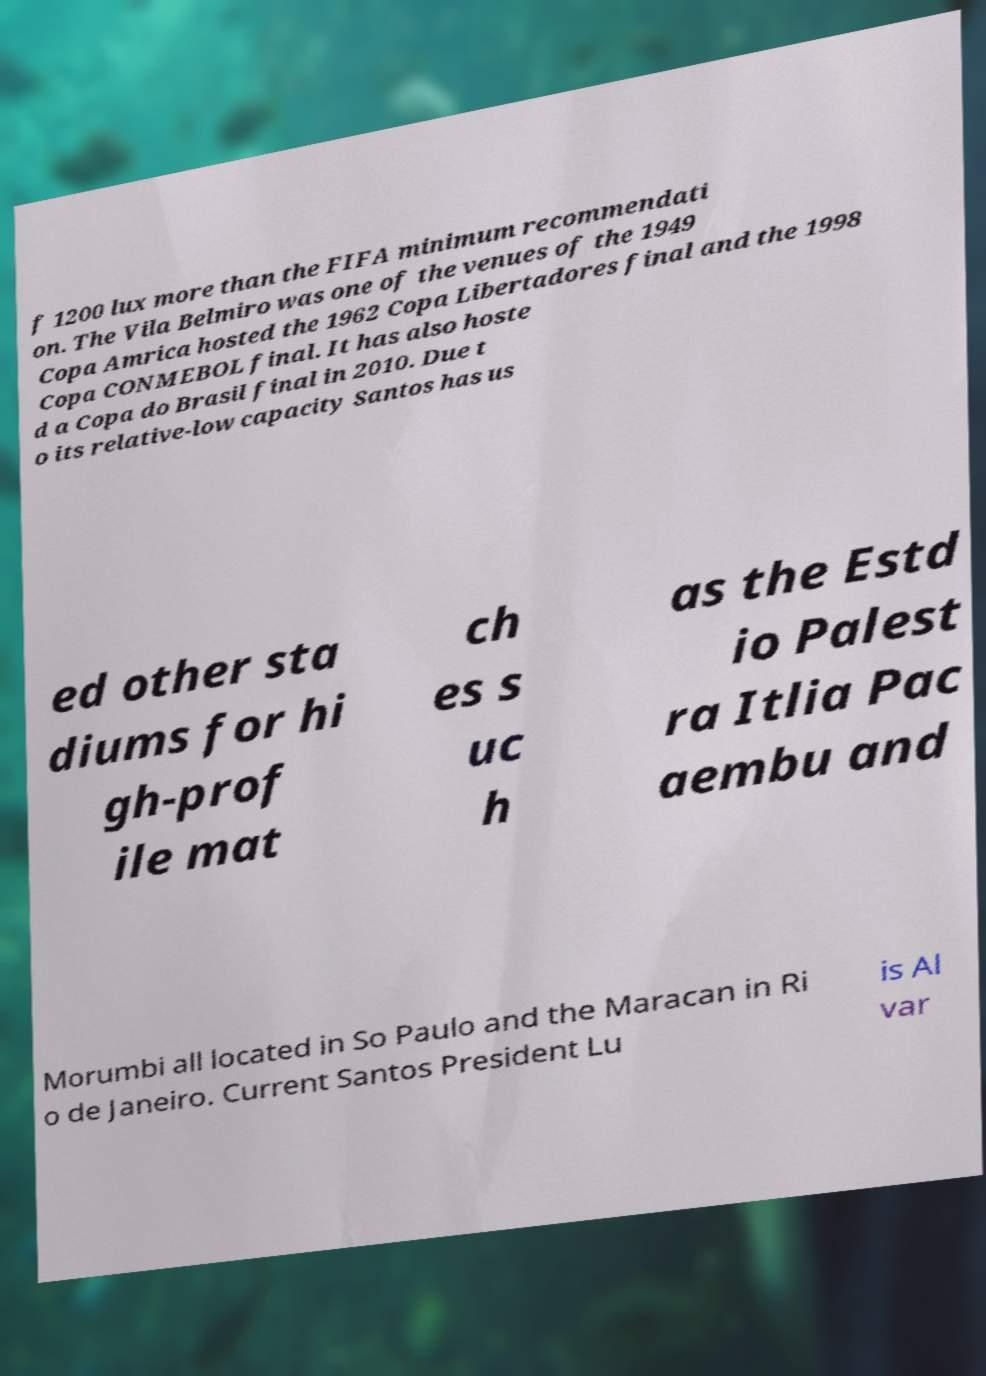Please read and relay the text visible in this image. What does it say? f 1200 lux more than the FIFA minimum recommendati on. The Vila Belmiro was one of the venues of the 1949 Copa Amrica hosted the 1962 Copa Libertadores final and the 1998 Copa CONMEBOL final. It has also hoste d a Copa do Brasil final in 2010. Due t o its relative-low capacity Santos has us ed other sta diums for hi gh-prof ile mat ch es s uc h as the Estd io Palest ra Itlia Pac aembu and Morumbi all located in So Paulo and the Maracan in Ri o de Janeiro. Current Santos President Lu is Al var 